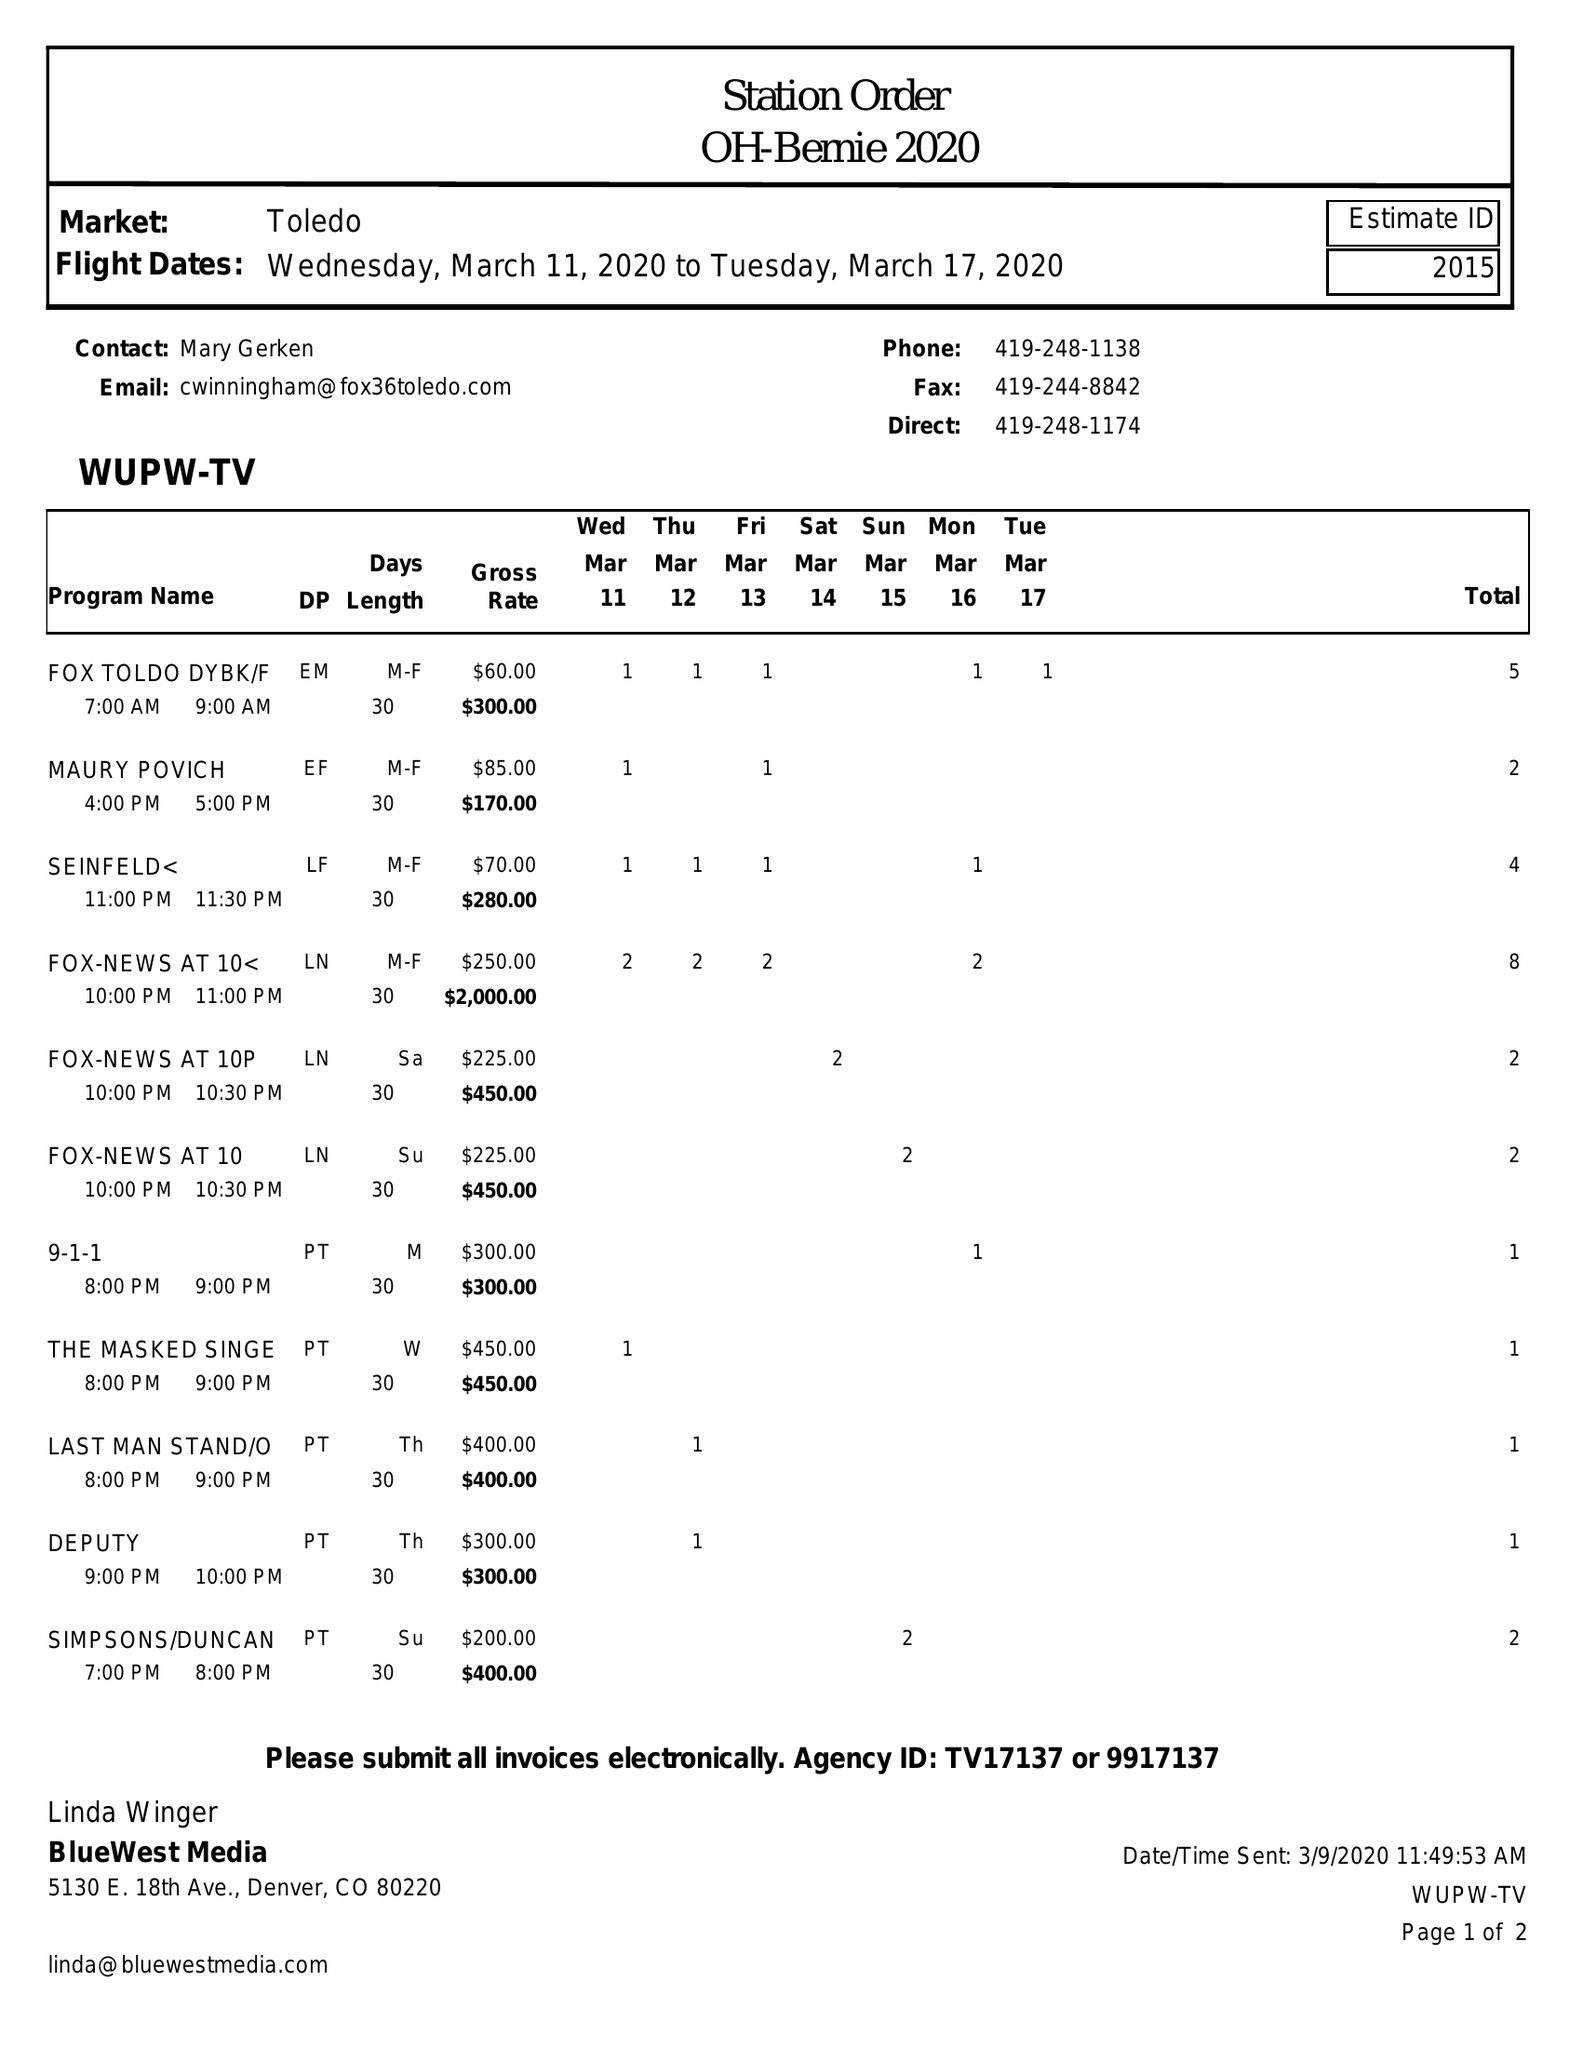What is the value for the gross_amount?
Answer the question using a single word or phrase. 5800.00 